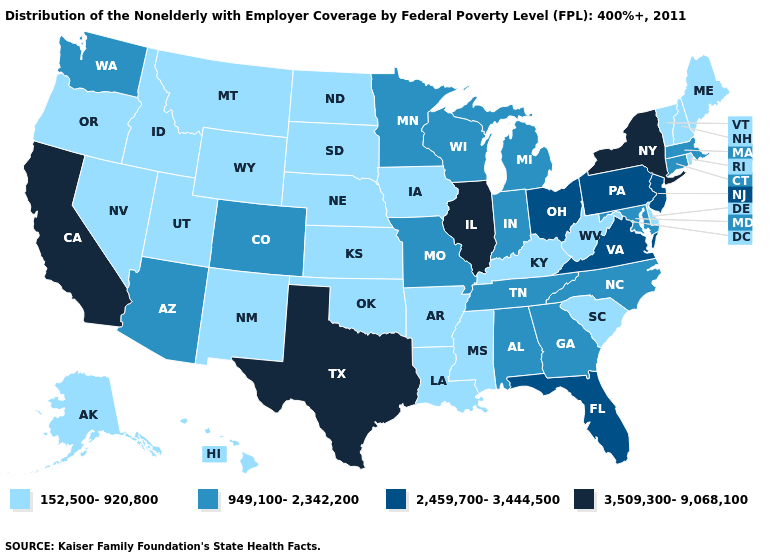What is the value of Tennessee?
Be succinct. 949,100-2,342,200. What is the lowest value in states that border North Dakota?
Be succinct. 152,500-920,800. Does New York have the highest value in the Northeast?
Keep it brief. Yes. What is the value of Connecticut?
Write a very short answer. 949,100-2,342,200. What is the value of Michigan?
Be succinct. 949,100-2,342,200. Name the states that have a value in the range 2,459,700-3,444,500?
Short answer required. Florida, New Jersey, Ohio, Pennsylvania, Virginia. Name the states that have a value in the range 3,509,300-9,068,100?
Quick response, please. California, Illinois, New York, Texas. Name the states that have a value in the range 3,509,300-9,068,100?
Give a very brief answer. California, Illinois, New York, Texas. What is the value of Iowa?
Be succinct. 152,500-920,800. Name the states that have a value in the range 949,100-2,342,200?
Give a very brief answer. Alabama, Arizona, Colorado, Connecticut, Georgia, Indiana, Maryland, Massachusetts, Michigan, Minnesota, Missouri, North Carolina, Tennessee, Washington, Wisconsin. Name the states that have a value in the range 3,509,300-9,068,100?
Keep it brief. California, Illinois, New York, Texas. What is the value of Alabama?
Keep it brief. 949,100-2,342,200. Does Oklahoma have the highest value in the South?
Answer briefly. No. Among the states that border Alabama , does Mississippi have the lowest value?
Be succinct. Yes. Name the states that have a value in the range 152,500-920,800?
Concise answer only. Alaska, Arkansas, Delaware, Hawaii, Idaho, Iowa, Kansas, Kentucky, Louisiana, Maine, Mississippi, Montana, Nebraska, Nevada, New Hampshire, New Mexico, North Dakota, Oklahoma, Oregon, Rhode Island, South Carolina, South Dakota, Utah, Vermont, West Virginia, Wyoming. 